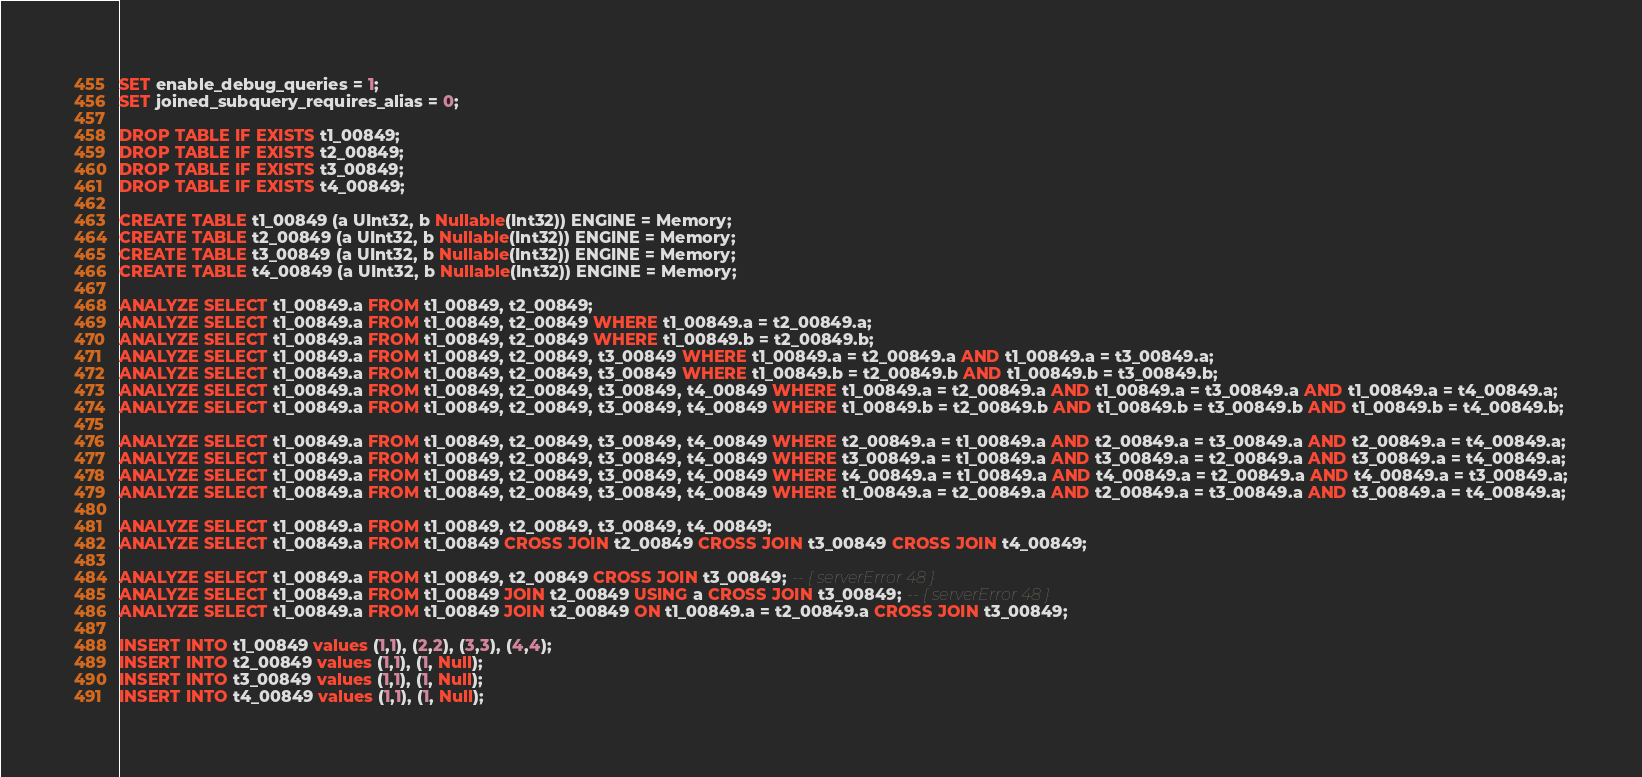<code> <loc_0><loc_0><loc_500><loc_500><_SQL_>SET enable_debug_queries = 1;
SET joined_subquery_requires_alias = 0;

DROP TABLE IF EXISTS t1_00849;
DROP TABLE IF EXISTS t2_00849;
DROP TABLE IF EXISTS t3_00849;
DROP TABLE IF EXISTS t4_00849;

CREATE TABLE t1_00849 (a UInt32, b Nullable(Int32)) ENGINE = Memory;
CREATE TABLE t2_00849 (a UInt32, b Nullable(Int32)) ENGINE = Memory;
CREATE TABLE t3_00849 (a UInt32, b Nullable(Int32)) ENGINE = Memory;
CREATE TABLE t4_00849 (a UInt32, b Nullable(Int32)) ENGINE = Memory;

ANALYZE SELECT t1_00849.a FROM t1_00849, t2_00849;
ANALYZE SELECT t1_00849.a FROM t1_00849, t2_00849 WHERE t1_00849.a = t2_00849.a;
ANALYZE SELECT t1_00849.a FROM t1_00849, t2_00849 WHERE t1_00849.b = t2_00849.b;
ANALYZE SELECT t1_00849.a FROM t1_00849, t2_00849, t3_00849 WHERE t1_00849.a = t2_00849.a AND t1_00849.a = t3_00849.a;
ANALYZE SELECT t1_00849.a FROM t1_00849, t2_00849, t3_00849 WHERE t1_00849.b = t2_00849.b AND t1_00849.b = t3_00849.b;
ANALYZE SELECT t1_00849.a FROM t1_00849, t2_00849, t3_00849, t4_00849 WHERE t1_00849.a = t2_00849.a AND t1_00849.a = t3_00849.a AND t1_00849.a = t4_00849.a;
ANALYZE SELECT t1_00849.a FROM t1_00849, t2_00849, t3_00849, t4_00849 WHERE t1_00849.b = t2_00849.b AND t1_00849.b = t3_00849.b AND t1_00849.b = t4_00849.b;

ANALYZE SELECT t1_00849.a FROM t1_00849, t2_00849, t3_00849, t4_00849 WHERE t2_00849.a = t1_00849.a AND t2_00849.a = t3_00849.a AND t2_00849.a = t4_00849.a;
ANALYZE SELECT t1_00849.a FROM t1_00849, t2_00849, t3_00849, t4_00849 WHERE t3_00849.a = t1_00849.a AND t3_00849.a = t2_00849.a AND t3_00849.a = t4_00849.a;
ANALYZE SELECT t1_00849.a FROM t1_00849, t2_00849, t3_00849, t4_00849 WHERE t4_00849.a = t1_00849.a AND t4_00849.a = t2_00849.a AND t4_00849.a = t3_00849.a;
ANALYZE SELECT t1_00849.a FROM t1_00849, t2_00849, t3_00849, t4_00849 WHERE t1_00849.a = t2_00849.a AND t2_00849.a = t3_00849.a AND t3_00849.a = t4_00849.a;

ANALYZE SELECT t1_00849.a FROM t1_00849, t2_00849, t3_00849, t4_00849;
ANALYZE SELECT t1_00849.a FROM t1_00849 CROSS JOIN t2_00849 CROSS JOIN t3_00849 CROSS JOIN t4_00849;

ANALYZE SELECT t1_00849.a FROM t1_00849, t2_00849 CROSS JOIN t3_00849; -- { serverError 48 }
ANALYZE SELECT t1_00849.a FROM t1_00849 JOIN t2_00849 USING a CROSS JOIN t3_00849; -- { serverError 48 }
ANALYZE SELECT t1_00849.a FROM t1_00849 JOIN t2_00849 ON t1_00849.a = t2_00849.a CROSS JOIN t3_00849;

INSERT INTO t1_00849 values (1,1), (2,2), (3,3), (4,4);
INSERT INTO t2_00849 values (1,1), (1, Null);
INSERT INTO t3_00849 values (1,1), (1, Null);
INSERT INTO t4_00849 values (1,1), (1, Null);
</code> 